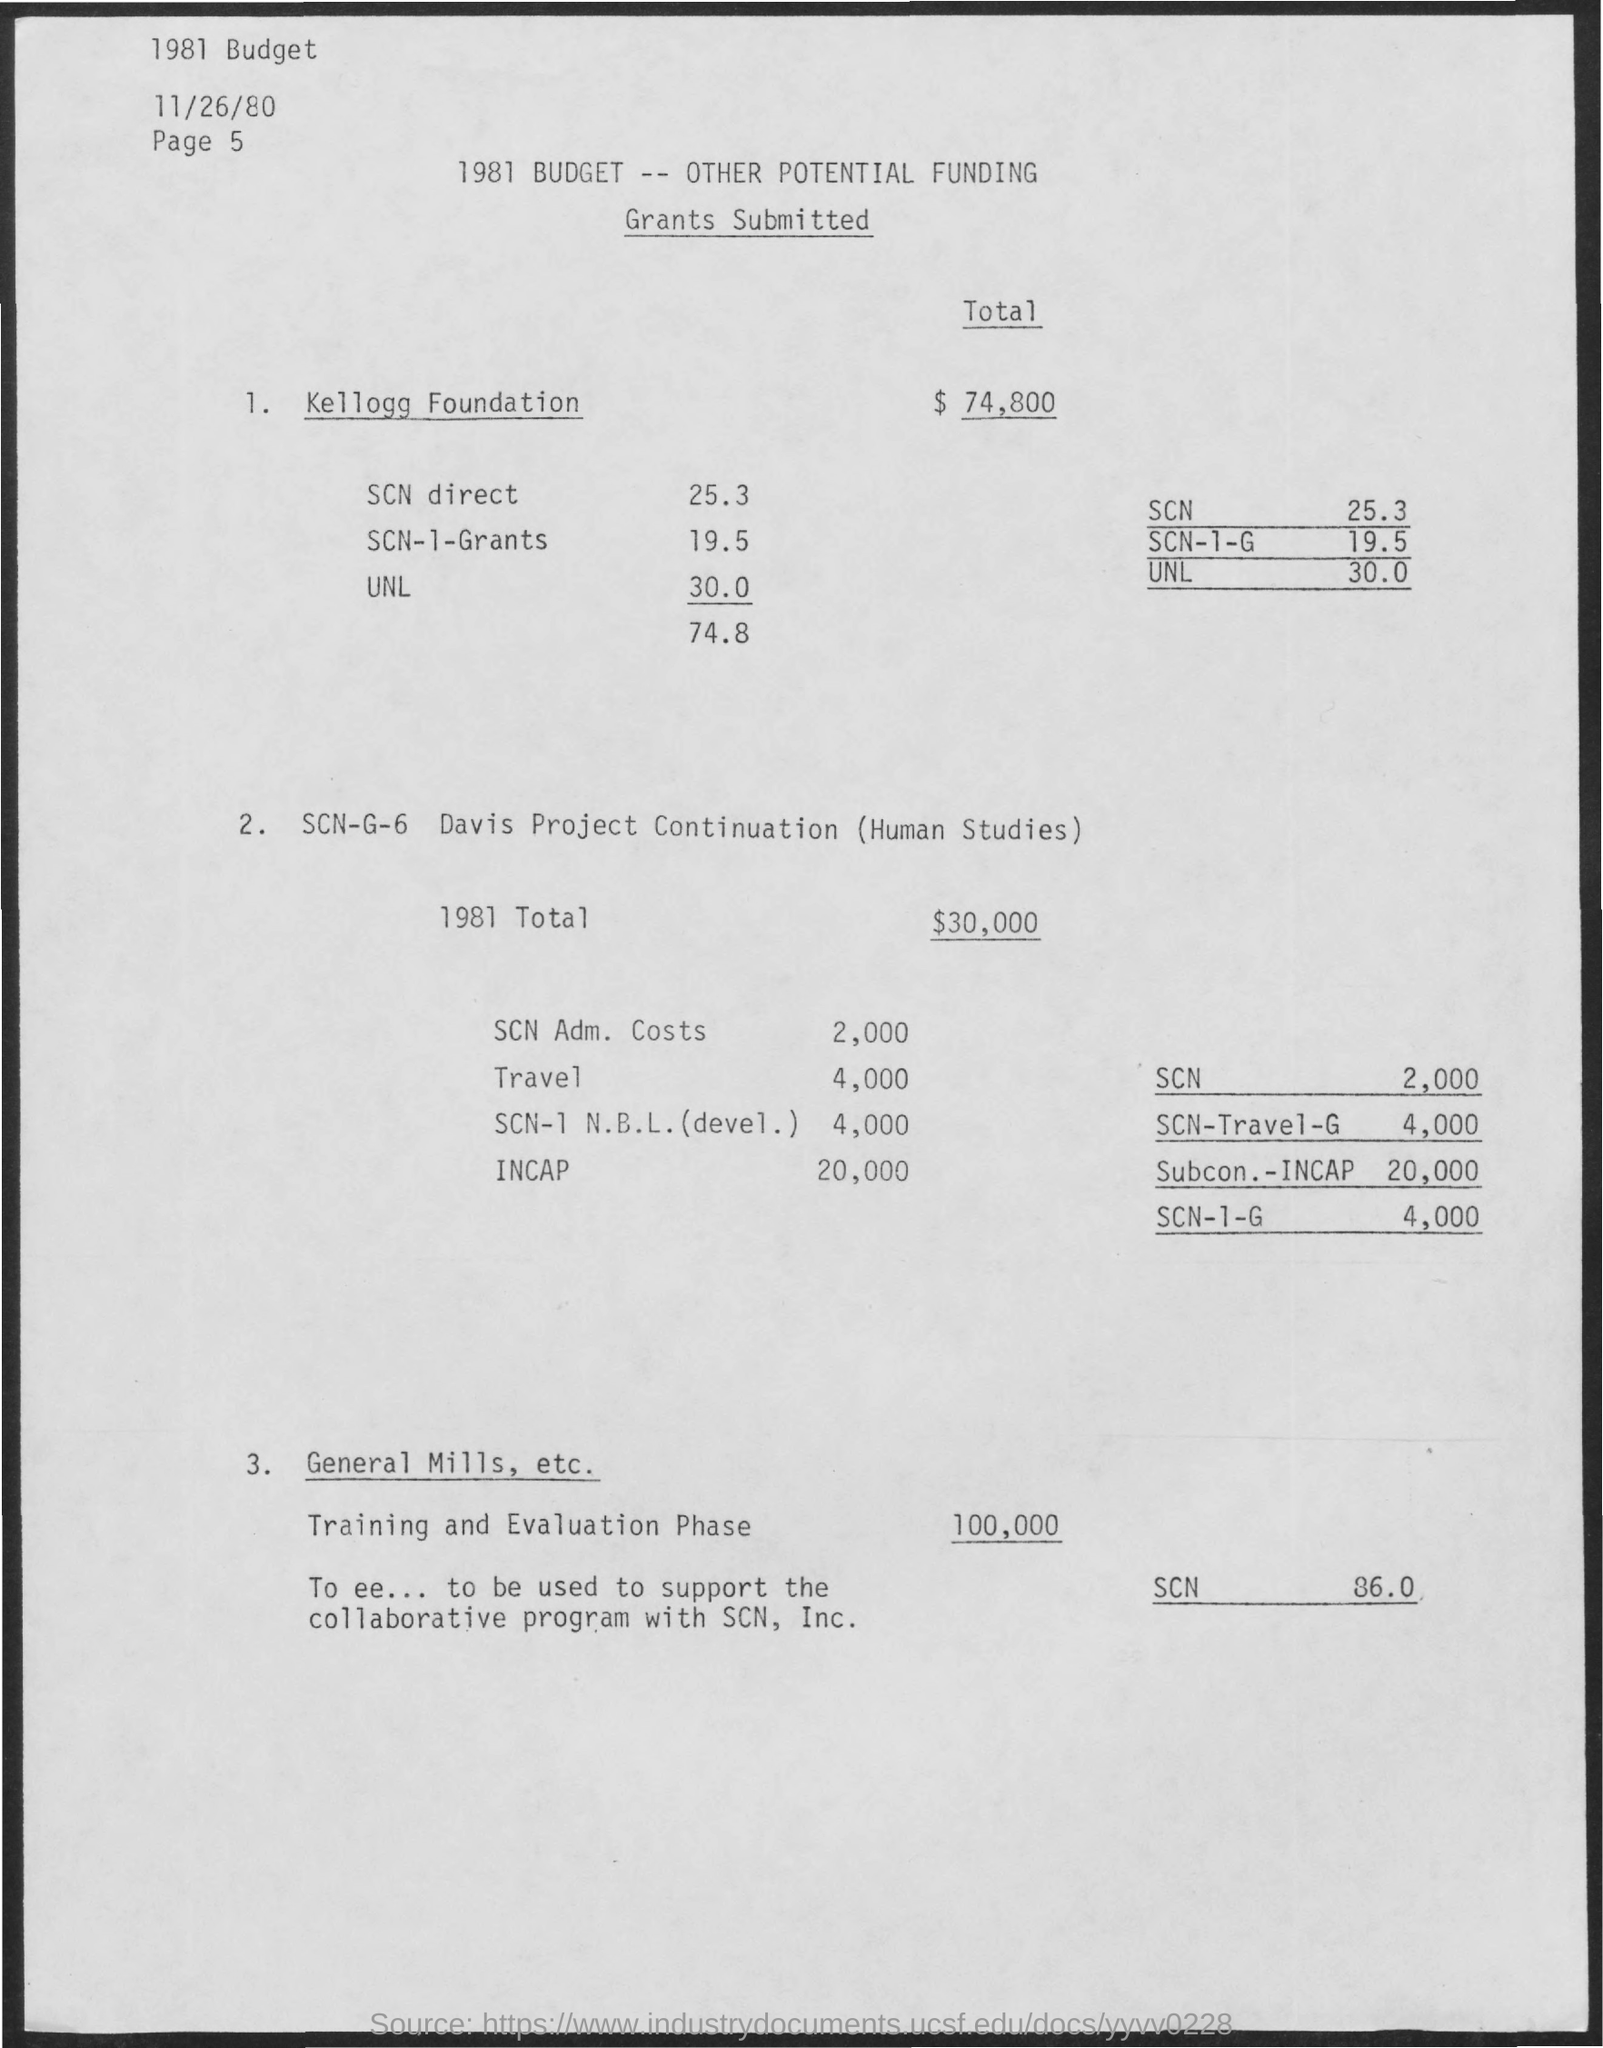Total fund for training and evaluation phase?
Provide a succinct answer. 100,000. 